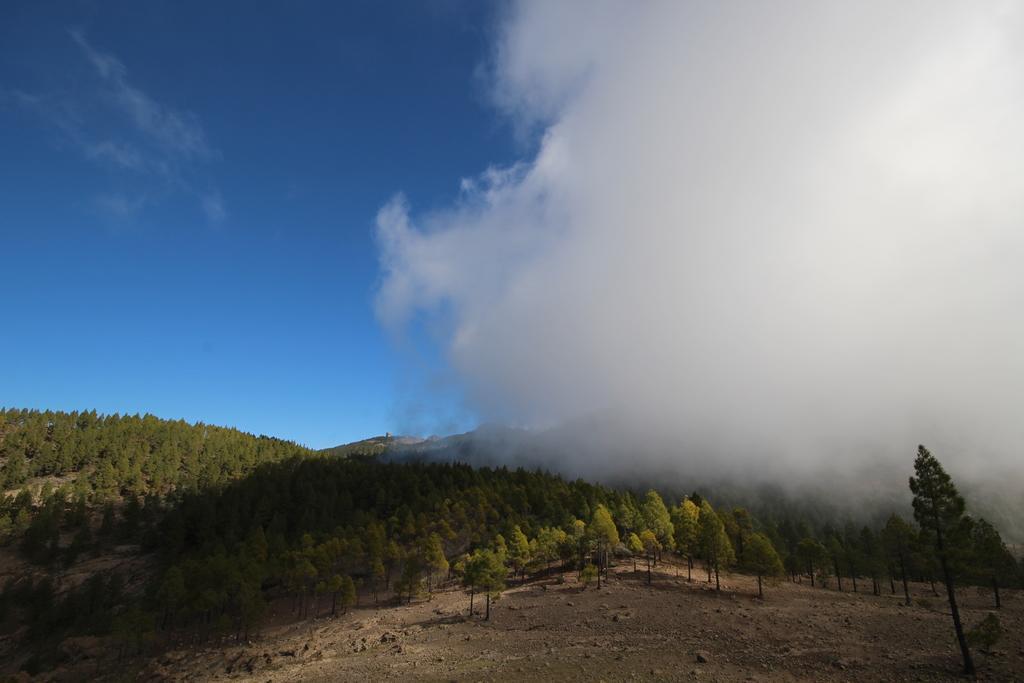In one or two sentences, can you explain what this image depicts? In this image we can see sky with clouds, trees and ground. 